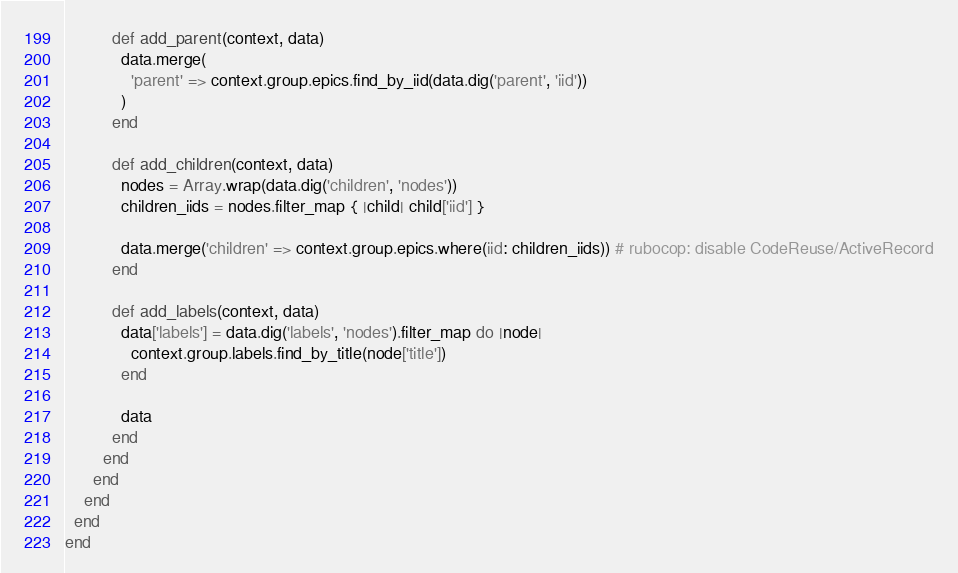Convert code to text. <code><loc_0><loc_0><loc_500><loc_500><_Ruby_>
          def add_parent(context, data)
            data.merge(
              'parent' => context.group.epics.find_by_iid(data.dig('parent', 'iid'))
            )
          end

          def add_children(context, data)
            nodes = Array.wrap(data.dig('children', 'nodes'))
            children_iids = nodes.filter_map { |child| child['iid'] }

            data.merge('children' => context.group.epics.where(iid: children_iids)) # rubocop: disable CodeReuse/ActiveRecord
          end

          def add_labels(context, data)
            data['labels'] = data.dig('labels', 'nodes').filter_map do |node|
              context.group.labels.find_by_title(node['title'])
            end

            data
          end
        end
      end
    end
  end
end
</code> 